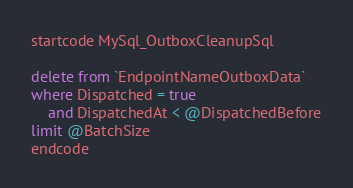Convert code to text. <code><loc_0><loc_0><loc_500><loc_500><_SQL_>startcode MySql_OutboxCleanupSql

delete from `EndpointNameOutboxData`
where Dispatched = true
    and DispatchedAt < @DispatchedBefore
limit @BatchSize
endcode
</code> 